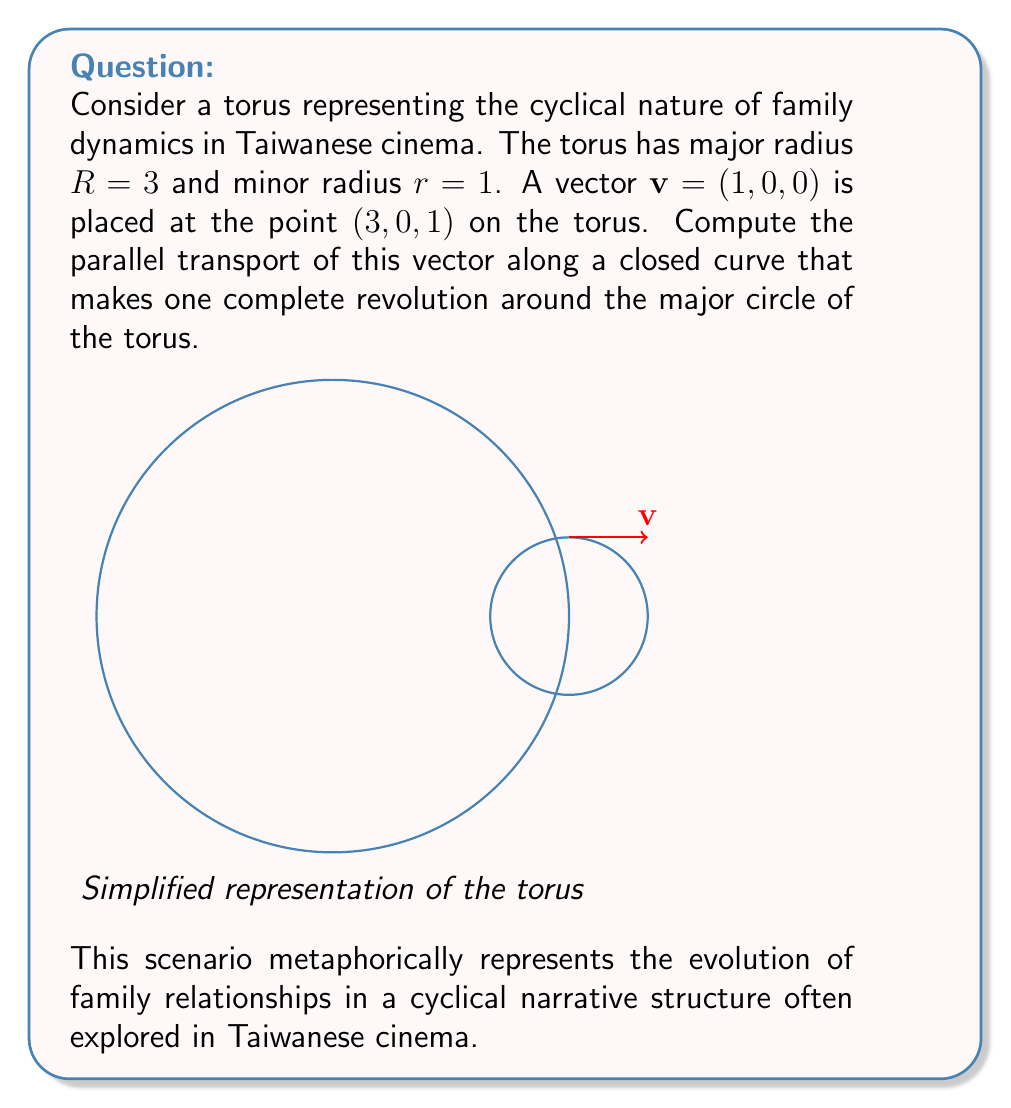Help me with this question. To solve this problem, we'll follow these steps:

1) First, recall that on a torus, parallel transport along a closed curve that goes around the major circle once results in a rotation of the vector.

2) The angle of rotation $\theta$ is given by the formula:
   
   $$\theta = 2\pi \frac{r}{R}$$

   where $r$ is the minor radius and $R$ is the major radius.

3) In this case, $r = 1$ and $R = 3$, so:

   $$\theta = 2\pi \frac{1}{3} = \frac{2\pi}{3}$$

4) Now, we need to rotate the vector $\mathbf{v} = (1, 0, 0)$ by this angle around the z-axis.

5) The rotation matrix for a counterclockwise rotation by angle $\theta$ around the z-axis is:

   $$\begin{pmatrix}
   \cos\theta & -\sin\theta & 0 \\
   \sin\theta & \cos\theta & 0 \\
   0 & 0 & 1
   \end{pmatrix}$$

6) Substituting $\theta = \frac{2\pi}{3}$:

   $$\begin{pmatrix}
   \cos(\frac{2\pi}{3}) & -\sin(\frac{2\pi}{3}) & 0 \\
   \sin(\frac{2\pi}{3}) & \cos(\frac{2\pi}{3}) & 0 \\
   0 & 0 & 1
   \end{pmatrix} = \begin{pmatrix}
   -\frac{1}{2} & -\frac{\sqrt{3}}{2} & 0 \\
   \frac{\sqrt{3}}{2} & -\frac{1}{2} & 0 \\
   0 & 0 & 1
   \end{pmatrix}$$

7) Multiplying this matrix by our vector $\mathbf{v} = (1, 0, 0)$:

   $$\begin{pmatrix}
   -\frac{1}{2} & -\frac{\sqrt{3}}{2} & 0 \\
   \frac{\sqrt{3}}{2} & -\frac{1}{2} & 0 \\
   0 & 0 & 1
   \end{pmatrix} \begin{pmatrix}
   1 \\ 0 \\ 0
   \end{pmatrix} = \begin{pmatrix}
   -\frac{1}{2} \\ \frac{\sqrt{3}}{2} \\ 0
   \end{pmatrix}$$

Therefore, after parallel transport, the vector $\mathbf{v}$ becomes $(-\frac{1}{2}, \frac{\sqrt{3}}{2}, 0)$.
Answer: $(-\frac{1}{2}, \frac{\sqrt{3}}{2}, 0)$ 